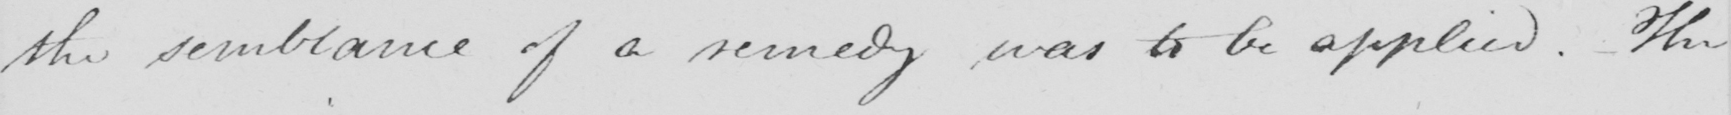What does this handwritten line say? the semblance of a remedy was to be applied . The 